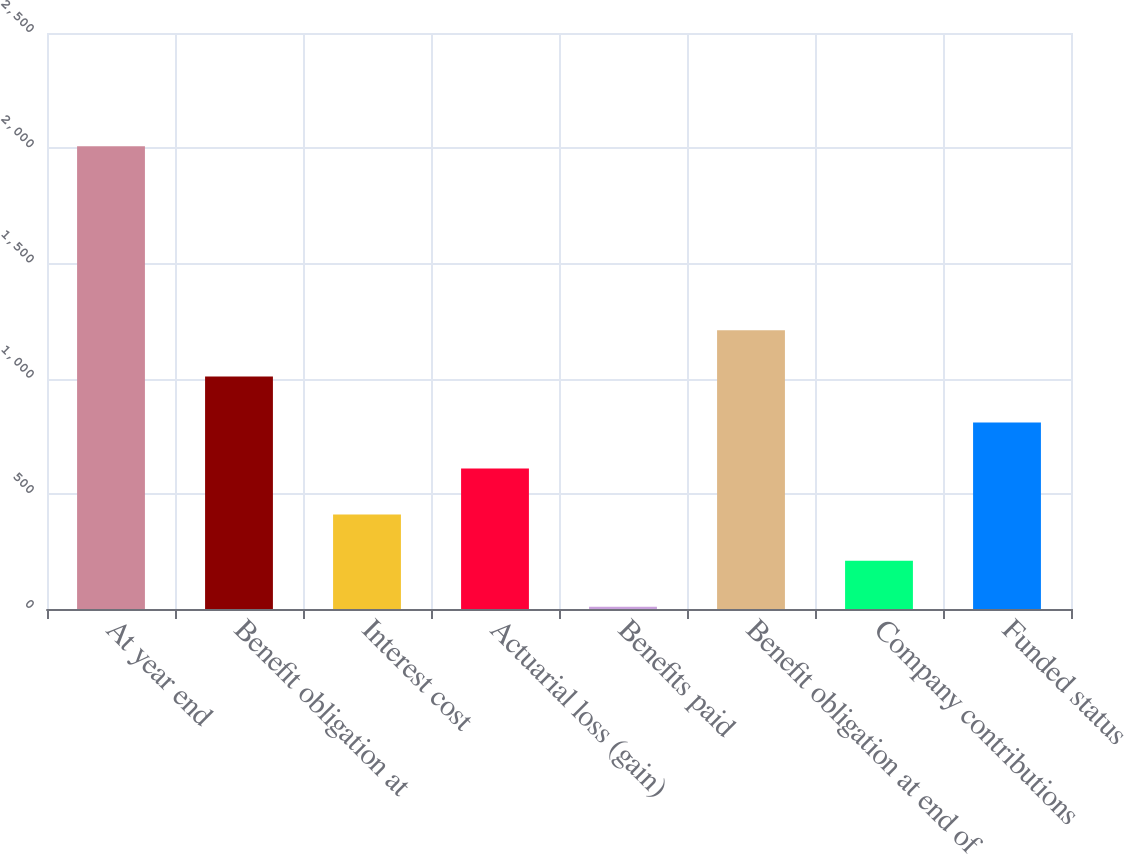Convert chart to OTSL. <chart><loc_0><loc_0><loc_500><loc_500><bar_chart><fcel>At year end<fcel>Benefit obligation at<fcel>Interest cost<fcel>Actuarial loss (gain)<fcel>Benefits paid<fcel>Benefit obligation at end of<fcel>Company contributions<fcel>Funded status<nl><fcel>2009<fcel>1009.5<fcel>409.8<fcel>609.7<fcel>10<fcel>1209.4<fcel>209.9<fcel>809.6<nl></chart> 